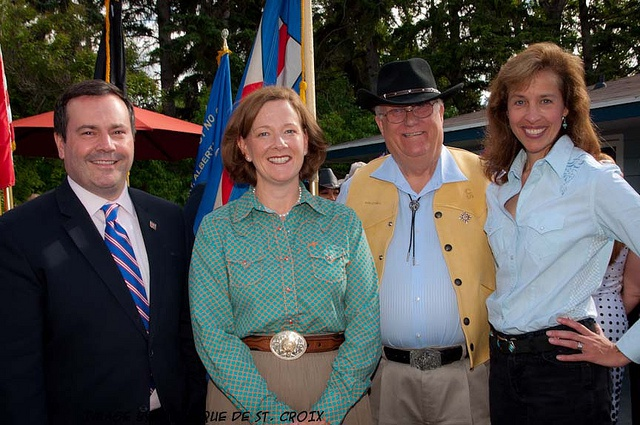Describe the objects in this image and their specific colors. I can see people in darkgreen, black, brown, and lightgray tones, people in darkgreen, black, darkgray, and brown tones, people in darkgreen, gray, and teal tones, people in darkgreen, darkgray, gray, tan, and black tones, and umbrella in darkgreen, black, salmon, and brown tones in this image. 